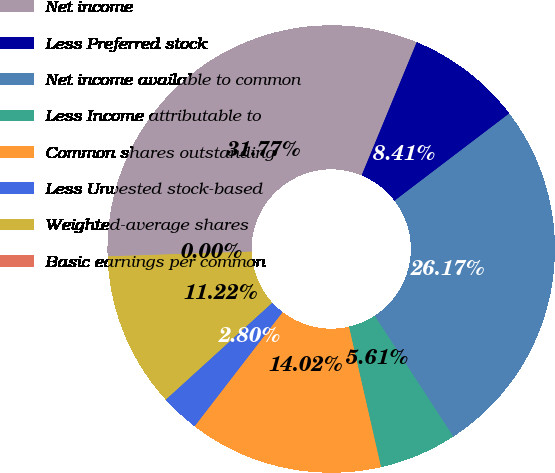Convert chart. <chart><loc_0><loc_0><loc_500><loc_500><pie_chart><fcel>Net income<fcel>Less Preferred stock<fcel>Net income available to common<fcel>Less Income attributable to<fcel>Common shares outstanding<fcel>Less Unvested stock-based<fcel>Weighted-average shares<fcel>Basic earnings per common<nl><fcel>31.77%<fcel>8.41%<fcel>26.17%<fcel>5.61%<fcel>14.02%<fcel>2.8%<fcel>11.22%<fcel>0.0%<nl></chart> 